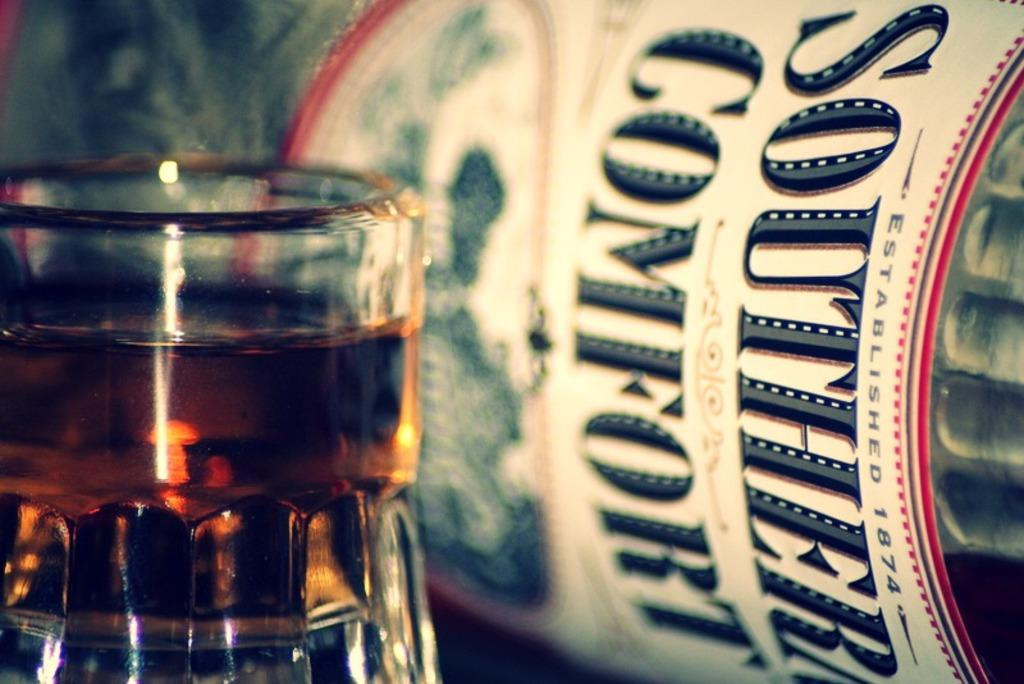<image>
Summarize the visual content of the image. A bottle of Southern Comfort is on its side next to a full glass. 